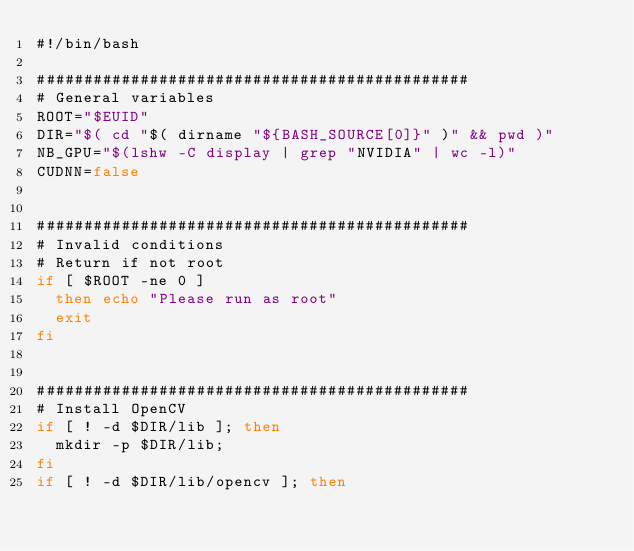Convert code to text. <code><loc_0><loc_0><loc_500><loc_500><_Bash_>#!/bin/bash

##############################################
# General variables
ROOT="$EUID"
DIR="$( cd "$( dirname "${BASH_SOURCE[0]}" )" && pwd )"
NB_GPU="$(lshw -C display | grep "NVIDIA" | wc -l)"
CUDNN=false


##############################################
# Invalid conditions
# Return if not root
if [ $ROOT -ne 0 ]
  then echo "Please run as root"
  exit
fi


##############################################
# Install OpenCV
if [ ! -d $DIR/lib ]; then
  mkdir -p $DIR/lib;
fi
if [ ! -d $DIR/lib/opencv ]; then</code> 